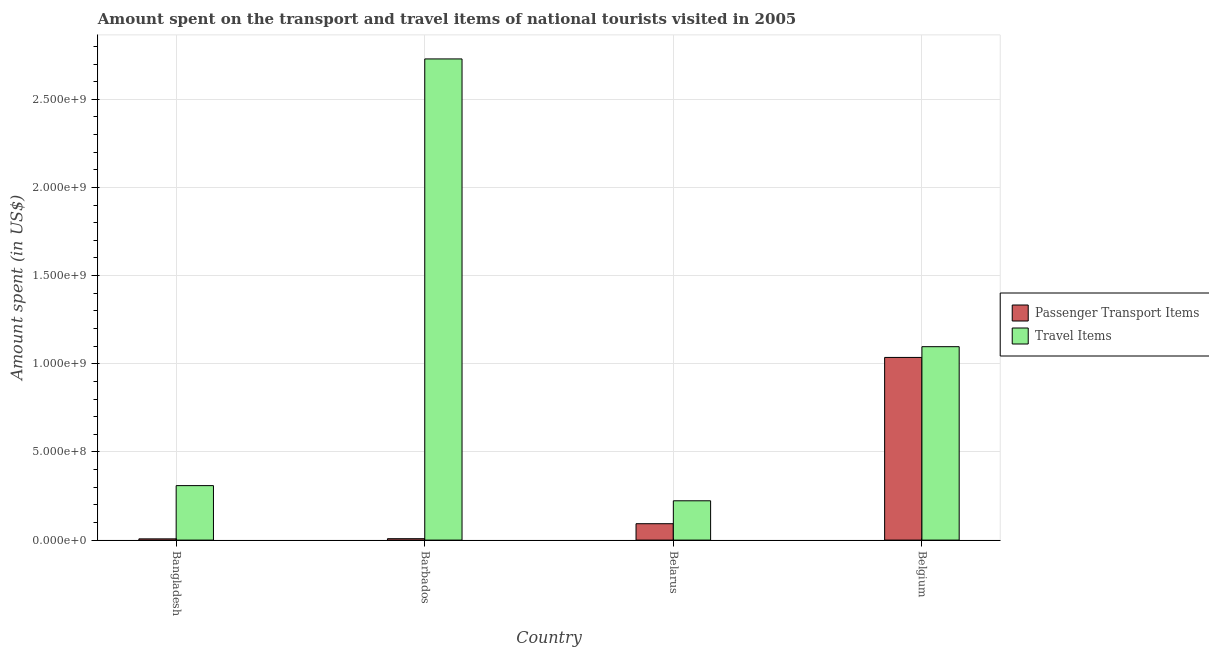How many groups of bars are there?
Your answer should be very brief. 4. Are the number of bars per tick equal to the number of legend labels?
Keep it short and to the point. Yes. Are the number of bars on each tick of the X-axis equal?
Your response must be concise. Yes. What is the label of the 2nd group of bars from the left?
Give a very brief answer. Barbados. In how many cases, is the number of bars for a given country not equal to the number of legend labels?
Keep it short and to the point. 0. What is the amount spent in travel items in Belgium?
Ensure brevity in your answer.  1.10e+09. Across all countries, what is the maximum amount spent in travel items?
Your answer should be very brief. 2.73e+09. Across all countries, what is the minimum amount spent in travel items?
Provide a short and direct response. 2.23e+08. In which country was the amount spent in travel items minimum?
Keep it short and to the point. Belarus. What is the total amount spent in travel items in the graph?
Offer a very short reply. 4.36e+09. What is the difference between the amount spent on passenger transport items in Barbados and that in Belarus?
Keep it short and to the point. -8.50e+07. What is the difference between the amount spent on passenger transport items in Belgium and the amount spent in travel items in Barbados?
Your answer should be compact. -1.69e+09. What is the average amount spent on passenger transport items per country?
Your response must be concise. 2.86e+08. What is the difference between the amount spent in travel items and amount spent on passenger transport items in Belgium?
Your response must be concise. 6.10e+07. In how many countries, is the amount spent in travel items greater than 1200000000 US$?
Your response must be concise. 1. What is the ratio of the amount spent on passenger transport items in Bangladesh to that in Belarus?
Provide a short and direct response. 0.08. Is the difference between the amount spent in travel items in Bangladesh and Belgium greater than the difference between the amount spent on passenger transport items in Bangladesh and Belgium?
Give a very brief answer. Yes. What is the difference between the highest and the second highest amount spent in travel items?
Give a very brief answer. 1.63e+09. What is the difference between the highest and the lowest amount spent on passenger transport items?
Ensure brevity in your answer.  1.03e+09. In how many countries, is the amount spent on passenger transport items greater than the average amount spent on passenger transport items taken over all countries?
Your answer should be compact. 1. Is the sum of the amount spent in travel items in Belarus and Belgium greater than the maximum amount spent on passenger transport items across all countries?
Keep it short and to the point. Yes. What does the 2nd bar from the left in Belarus represents?
Make the answer very short. Travel Items. What does the 2nd bar from the right in Barbados represents?
Keep it short and to the point. Passenger Transport Items. How many bars are there?
Provide a short and direct response. 8. Are all the bars in the graph horizontal?
Your answer should be very brief. No. How many countries are there in the graph?
Keep it short and to the point. 4. Does the graph contain grids?
Provide a succinct answer. Yes. Where does the legend appear in the graph?
Provide a succinct answer. Center right. How many legend labels are there?
Ensure brevity in your answer.  2. How are the legend labels stacked?
Provide a succinct answer. Vertical. What is the title of the graph?
Provide a succinct answer. Amount spent on the transport and travel items of national tourists visited in 2005. What is the label or title of the Y-axis?
Your response must be concise. Amount spent (in US$). What is the Amount spent (in US$) in Travel Items in Bangladesh?
Offer a terse response. 3.09e+08. What is the Amount spent (in US$) of Passenger Transport Items in Barbados?
Keep it short and to the point. 8.00e+06. What is the Amount spent (in US$) of Travel Items in Barbados?
Keep it short and to the point. 2.73e+09. What is the Amount spent (in US$) in Passenger Transport Items in Belarus?
Your answer should be very brief. 9.30e+07. What is the Amount spent (in US$) in Travel Items in Belarus?
Offer a terse response. 2.23e+08. What is the Amount spent (in US$) in Passenger Transport Items in Belgium?
Your response must be concise. 1.04e+09. What is the Amount spent (in US$) in Travel Items in Belgium?
Your answer should be compact. 1.10e+09. Across all countries, what is the maximum Amount spent (in US$) in Passenger Transport Items?
Your answer should be compact. 1.04e+09. Across all countries, what is the maximum Amount spent (in US$) of Travel Items?
Provide a succinct answer. 2.73e+09. Across all countries, what is the minimum Amount spent (in US$) in Travel Items?
Provide a short and direct response. 2.23e+08. What is the total Amount spent (in US$) of Passenger Transport Items in the graph?
Make the answer very short. 1.14e+09. What is the total Amount spent (in US$) of Travel Items in the graph?
Provide a short and direct response. 4.36e+09. What is the difference between the Amount spent (in US$) in Passenger Transport Items in Bangladesh and that in Barbados?
Ensure brevity in your answer.  -1.00e+06. What is the difference between the Amount spent (in US$) of Travel Items in Bangladesh and that in Barbados?
Make the answer very short. -2.42e+09. What is the difference between the Amount spent (in US$) in Passenger Transport Items in Bangladesh and that in Belarus?
Make the answer very short. -8.60e+07. What is the difference between the Amount spent (in US$) in Travel Items in Bangladesh and that in Belarus?
Your answer should be very brief. 8.60e+07. What is the difference between the Amount spent (in US$) of Passenger Transport Items in Bangladesh and that in Belgium?
Give a very brief answer. -1.03e+09. What is the difference between the Amount spent (in US$) of Travel Items in Bangladesh and that in Belgium?
Keep it short and to the point. -7.88e+08. What is the difference between the Amount spent (in US$) of Passenger Transport Items in Barbados and that in Belarus?
Offer a terse response. -8.50e+07. What is the difference between the Amount spent (in US$) of Travel Items in Barbados and that in Belarus?
Offer a terse response. 2.51e+09. What is the difference between the Amount spent (in US$) in Passenger Transport Items in Barbados and that in Belgium?
Offer a very short reply. -1.03e+09. What is the difference between the Amount spent (in US$) of Travel Items in Barbados and that in Belgium?
Provide a short and direct response. 1.63e+09. What is the difference between the Amount spent (in US$) in Passenger Transport Items in Belarus and that in Belgium?
Your answer should be very brief. -9.43e+08. What is the difference between the Amount spent (in US$) in Travel Items in Belarus and that in Belgium?
Make the answer very short. -8.74e+08. What is the difference between the Amount spent (in US$) of Passenger Transport Items in Bangladesh and the Amount spent (in US$) of Travel Items in Barbados?
Offer a terse response. -2.72e+09. What is the difference between the Amount spent (in US$) of Passenger Transport Items in Bangladesh and the Amount spent (in US$) of Travel Items in Belarus?
Your answer should be compact. -2.16e+08. What is the difference between the Amount spent (in US$) of Passenger Transport Items in Bangladesh and the Amount spent (in US$) of Travel Items in Belgium?
Offer a terse response. -1.09e+09. What is the difference between the Amount spent (in US$) of Passenger Transport Items in Barbados and the Amount spent (in US$) of Travel Items in Belarus?
Ensure brevity in your answer.  -2.15e+08. What is the difference between the Amount spent (in US$) of Passenger Transport Items in Barbados and the Amount spent (in US$) of Travel Items in Belgium?
Give a very brief answer. -1.09e+09. What is the difference between the Amount spent (in US$) in Passenger Transport Items in Belarus and the Amount spent (in US$) in Travel Items in Belgium?
Offer a very short reply. -1.00e+09. What is the average Amount spent (in US$) in Passenger Transport Items per country?
Keep it short and to the point. 2.86e+08. What is the average Amount spent (in US$) in Travel Items per country?
Your answer should be compact. 1.09e+09. What is the difference between the Amount spent (in US$) of Passenger Transport Items and Amount spent (in US$) of Travel Items in Bangladesh?
Your answer should be very brief. -3.02e+08. What is the difference between the Amount spent (in US$) of Passenger Transport Items and Amount spent (in US$) of Travel Items in Barbados?
Make the answer very short. -2.72e+09. What is the difference between the Amount spent (in US$) of Passenger Transport Items and Amount spent (in US$) of Travel Items in Belarus?
Provide a succinct answer. -1.30e+08. What is the difference between the Amount spent (in US$) in Passenger Transport Items and Amount spent (in US$) in Travel Items in Belgium?
Ensure brevity in your answer.  -6.10e+07. What is the ratio of the Amount spent (in US$) in Passenger Transport Items in Bangladesh to that in Barbados?
Provide a short and direct response. 0.88. What is the ratio of the Amount spent (in US$) in Travel Items in Bangladesh to that in Barbados?
Make the answer very short. 0.11. What is the ratio of the Amount spent (in US$) in Passenger Transport Items in Bangladesh to that in Belarus?
Your response must be concise. 0.08. What is the ratio of the Amount spent (in US$) in Travel Items in Bangladesh to that in Belarus?
Provide a succinct answer. 1.39. What is the ratio of the Amount spent (in US$) in Passenger Transport Items in Bangladesh to that in Belgium?
Provide a short and direct response. 0.01. What is the ratio of the Amount spent (in US$) of Travel Items in Bangladesh to that in Belgium?
Keep it short and to the point. 0.28. What is the ratio of the Amount spent (in US$) of Passenger Transport Items in Barbados to that in Belarus?
Make the answer very short. 0.09. What is the ratio of the Amount spent (in US$) in Travel Items in Barbados to that in Belarus?
Provide a succinct answer. 12.24. What is the ratio of the Amount spent (in US$) of Passenger Transport Items in Barbados to that in Belgium?
Make the answer very short. 0.01. What is the ratio of the Amount spent (in US$) of Travel Items in Barbados to that in Belgium?
Provide a short and direct response. 2.49. What is the ratio of the Amount spent (in US$) of Passenger Transport Items in Belarus to that in Belgium?
Provide a short and direct response. 0.09. What is the ratio of the Amount spent (in US$) in Travel Items in Belarus to that in Belgium?
Your answer should be very brief. 0.2. What is the difference between the highest and the second highest Amount spent (in US$) in Passenger Transport Items?
Offer a terse response. 9.43e+08. What is the difference between the highest and the second highest Amount spent (in US$) of Travel Items?
Your answer should be compact. 1.63e+09. What is the difference between the highest and the lowest Amount spent (in US$) in Passenger Transport Items?
Provide a succinct answer. 1.03e+09. What is the difference between the highest and the lowest Amount spent (in US$) of Travel Items?
Ensure brevity in your answer.  2.51e+09. 